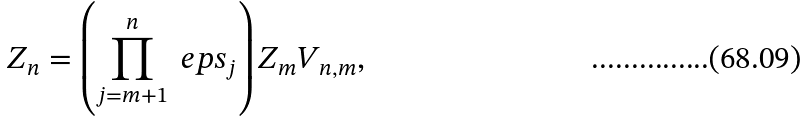Convert formula to latex. <formula><loc_0><loc_0><loc_500><loc_500>Z _ { n } = \left ( \prod _ { j = m + 1 } ^ { n } \ e p s _ { j } \right ) Z _ { m } V _ { n , m } ,</formula> 